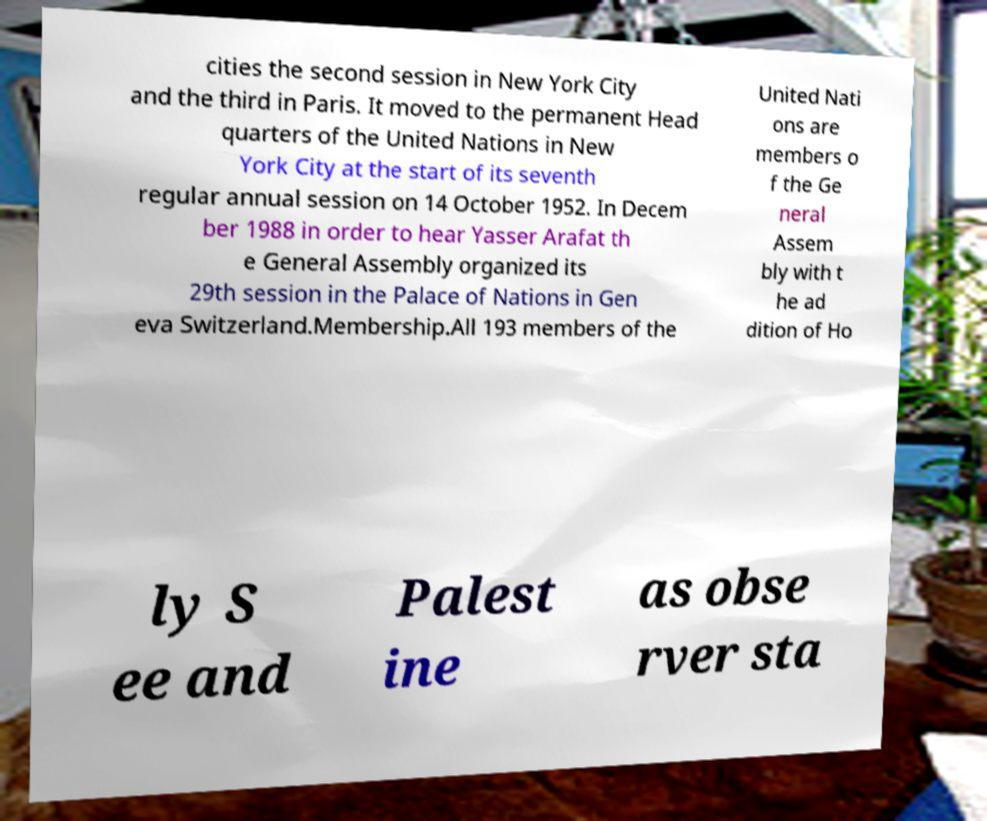Could you assist in decoding the text presented in this image and type it out clearly? cities the second session in New York City and the third in Paris. It moved to the permanent Head quarters of the United Nations in New York City at the start of its seventh regular annual session on 14 October 1952. In Decem ber 1988 in order to hear Yasser Arafat th e General Assembly organized its 29th session in the Palace of Nations in Gen eva Switzerland.Membership.All 193 members of the United Nati ons are members o f the Ge neral Assem bly with t he ad dition of Ho ly S ee and Palest ine as obse rver sta 